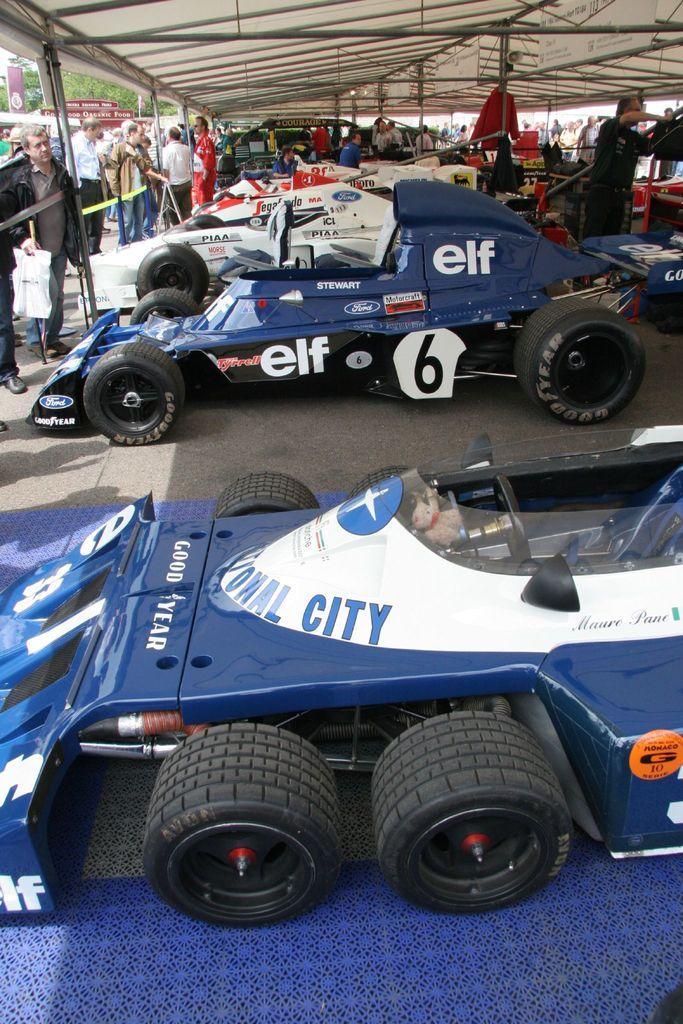How would you summarize this image in a sentence or two? Here in this picture we can see F1 racing cars present on the ground, under a shed and we can also see number of people standing all over there and in the far we can see plants and trees present and we can also see hoardings present. 